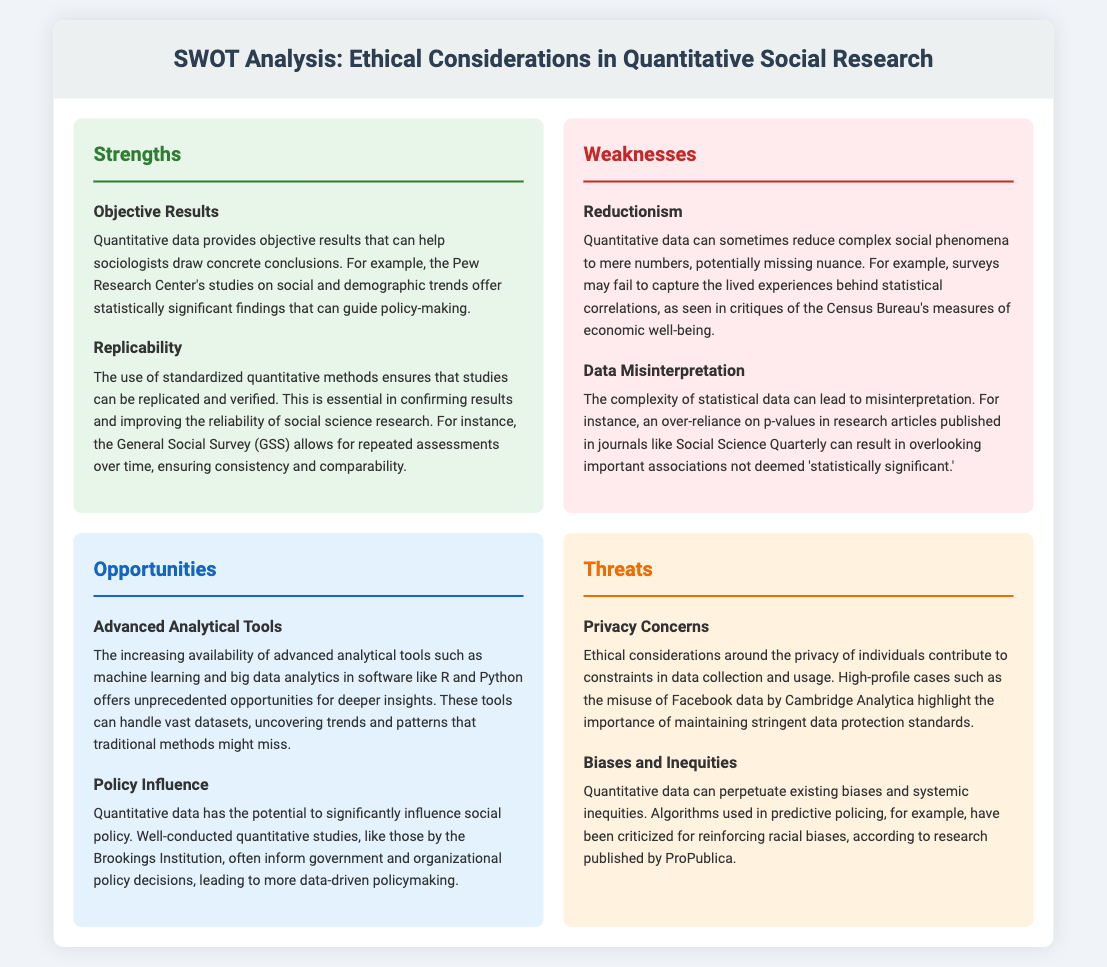What is the title of the document? The title of the document is found at the top of the rendered HTML, summarizing the content it covers.
Answer: SWOT Analysis: Ethical Considerations in Quantitative Social Research What are the two strengths mentioned? The strengths are detailed in the strengths section, highlighting particular advantages of quantitative data in social research.
Answer: Objective Results, Replicability What is one example of data misinterpretation? The example given in the weaknesses section illustrates a common issue with statistical results being misunderstood in social articles.
Answer: Over-reliance on p-values What advanced tool is mentioned as an opportunity? The opportunities section identifies a key tool that provides deeper insights into quantitative data through technology advancements.
Answer: Machine learning What ethical concern is raised regarding privacy? The threats section discusses a significant ethical issue faced by researchers and institutions when handling data.
Answer: Privacy Concerns How can quantitative data influence social policy? This question pertains to the potential impact and relevance of conducting well-researched quantitative studies in policymaking.
Answer: Policy Influence What challenge does bias in quantitative data represent? The threats section highlights a systemic issue that arises from the misapplication or interpretation of quantitative findings.
Answer: Biases and Inequities Which organization is mentioned as conducting significant quantitative studies? The opportunities section references an important research institution that plays a role in shaping data-informed policies.
Answer: Brookings Institution 